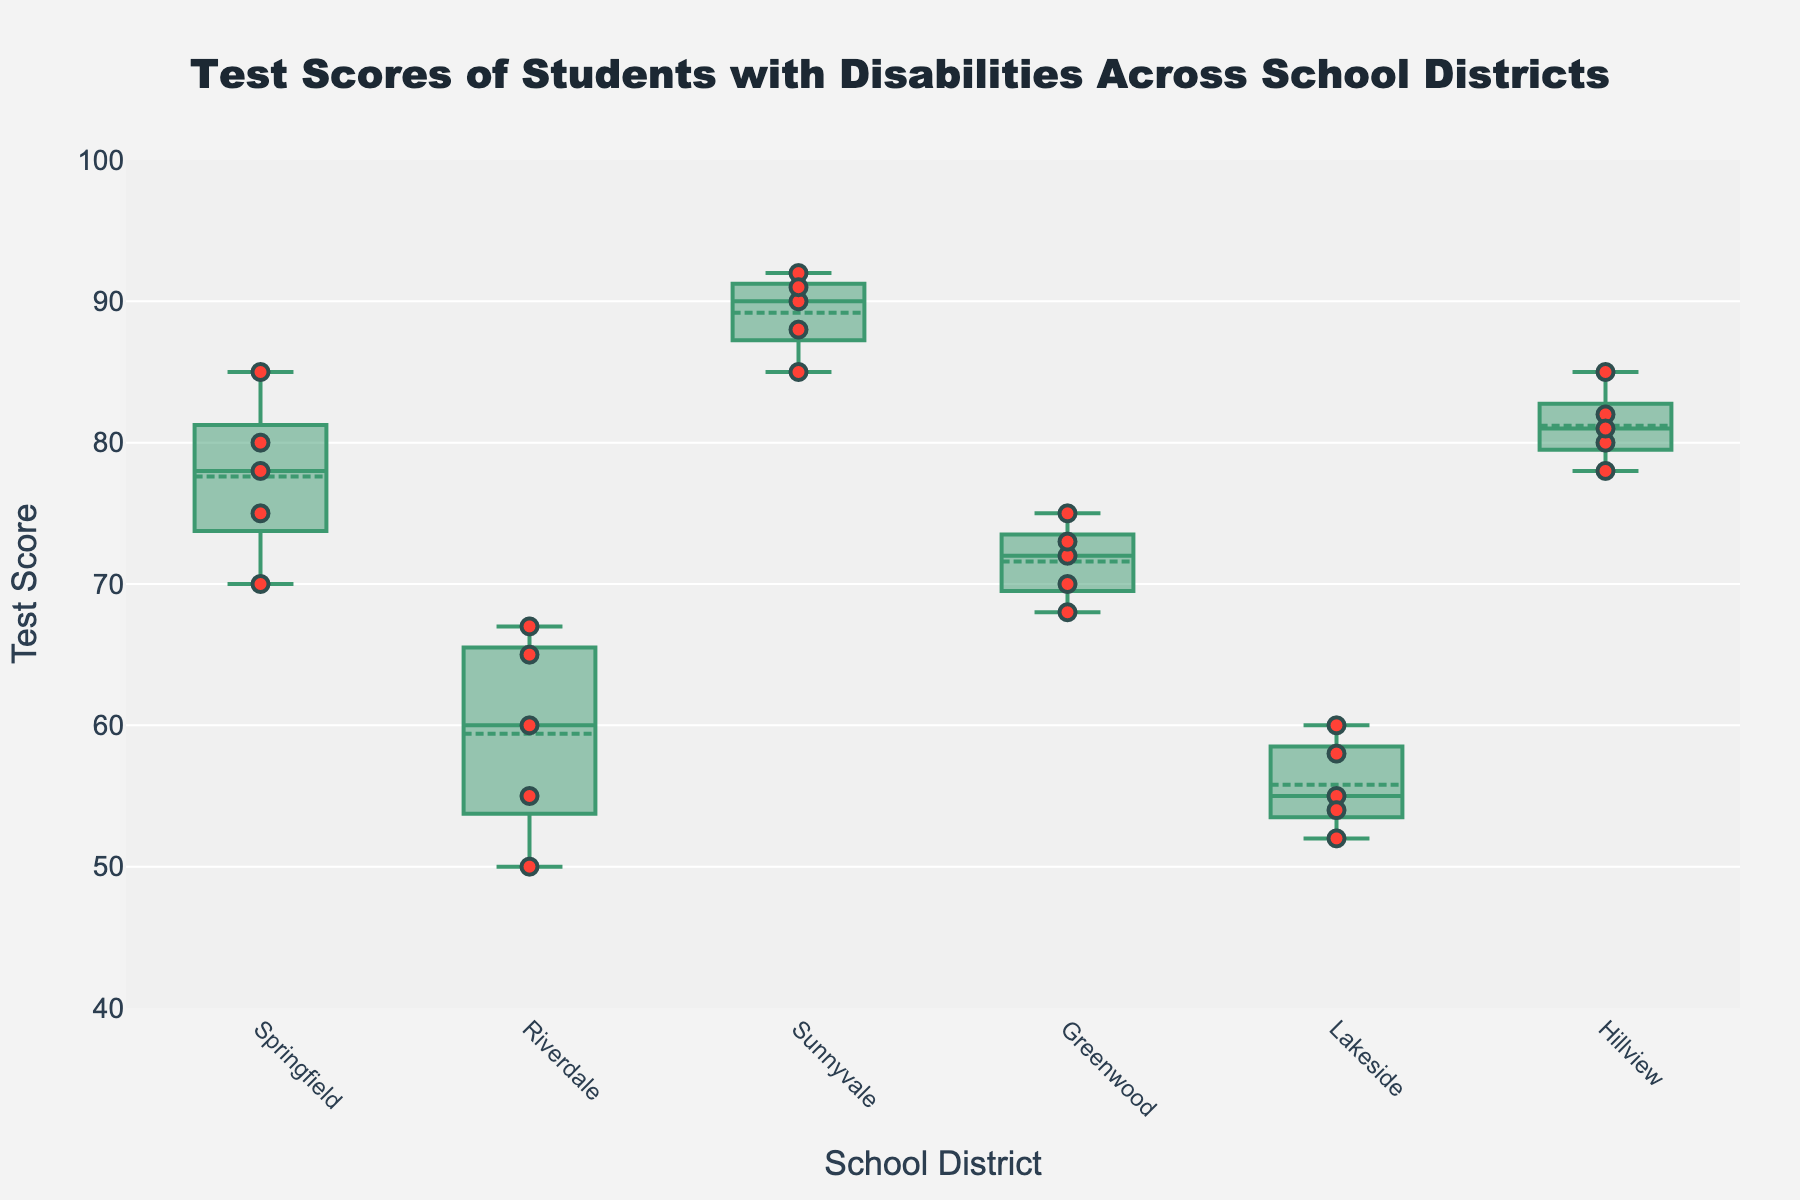What is the title of the figure? The title is located at the top of the figure, centered, and in a large, bold font. It says, "Test Scores of Students with Disabilities Across School Districts."
Answer: Test Scores of Students with Disabilities Across School Districts Which district has the lowest median test score? By observing the middle line of each box plot, Riverdale's box plot has the lowest median test score compared to the other districts.
Answer: Riverdale How many individual test scores are plotted for Hillview? There are five scatter points shown within the box plot for Hillview, corresponding to the five test scores.
Answer: 5 What is the interquartile range (IQR) of test scores for Springfield? The IQR is the distance between the first quartile (Q1) and the third quartile (Q3). For Springfield, Q1 and Q3 lines in the box plot are around 73 and 82, respectively. Therefore, IQR = 82 - 73.
Answer: 9 Which district has the most consistent (least spread out) test scores? By looking at the width of the box plots, Sunnyvale has the most consistent test scores as its box plot is the narrowest, indicating a smaller range between Q1 and Q3.
Answer: Sunnyvale Compare the highest test score in Springfield to the highest in Lakeside. Which one is higher and by how much? The highest point in Springfield's scatter plot is 85, and in Lakeside, it is 60. The difference is 85 - 60.
Answer: Springfield by 25 Which district has the largest range in test scores? The range is the distance between the lowest and highest points in the scatter plot. Riverdale has the largest range with scores from 50 to 67.
Answer: Riverdale What is the median test score for Sunnyvale? The median is the middle value in the box plot, represented by the line inside the box. For Sunnyvale, the median test score is around 90.
Answer: 90 What test score appears most frequently across all districts? By looking at the scatter points, the test score of 85 appears frequently in both Springfield and Sunnyvale.
Answer: 85 How does the median test score of Hillview compare to the median of Greenwood? The median in Hillview is around 81, and in Greenwood, it is around 72. This indicates Hillview's median is higher.
Answer: Hillview is higher 